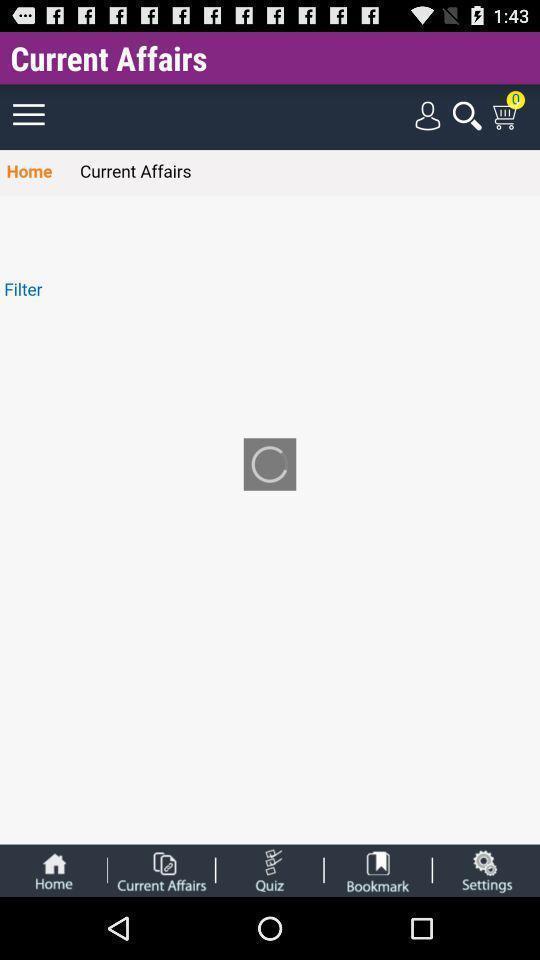What can you discern from this picture? Learning application displayed current affairs loading page and other options. 